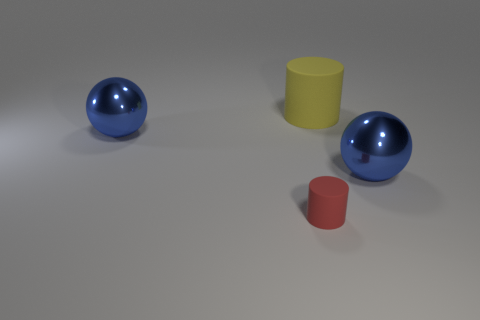Add 1 matte cylinders. How many objects exist? 5 Subtract 1 cylinders. How many cylinders are left? 1 Add 1 tiny rubber cylinders. How many tiny rubber cylinders exist? 2 Subtract 0 yellow cubes. How many objects are left? 4 Subtract all purple balls. Subtract all green cylinders. How many balls are left? 2 Subtract all yellow matte cylinders. Subtract all small gray spheres. How many objects are left? 3 Add 4 big shiny objects. How many big shiny objects are left? 6 